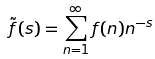<formula> <loc_0><loc_0><loc_500><loc_500>\tilde { f } ( s ) = \sum _ { n = 1 } ^ { \infty } f ( n ) n ^ { - s }</formula> 